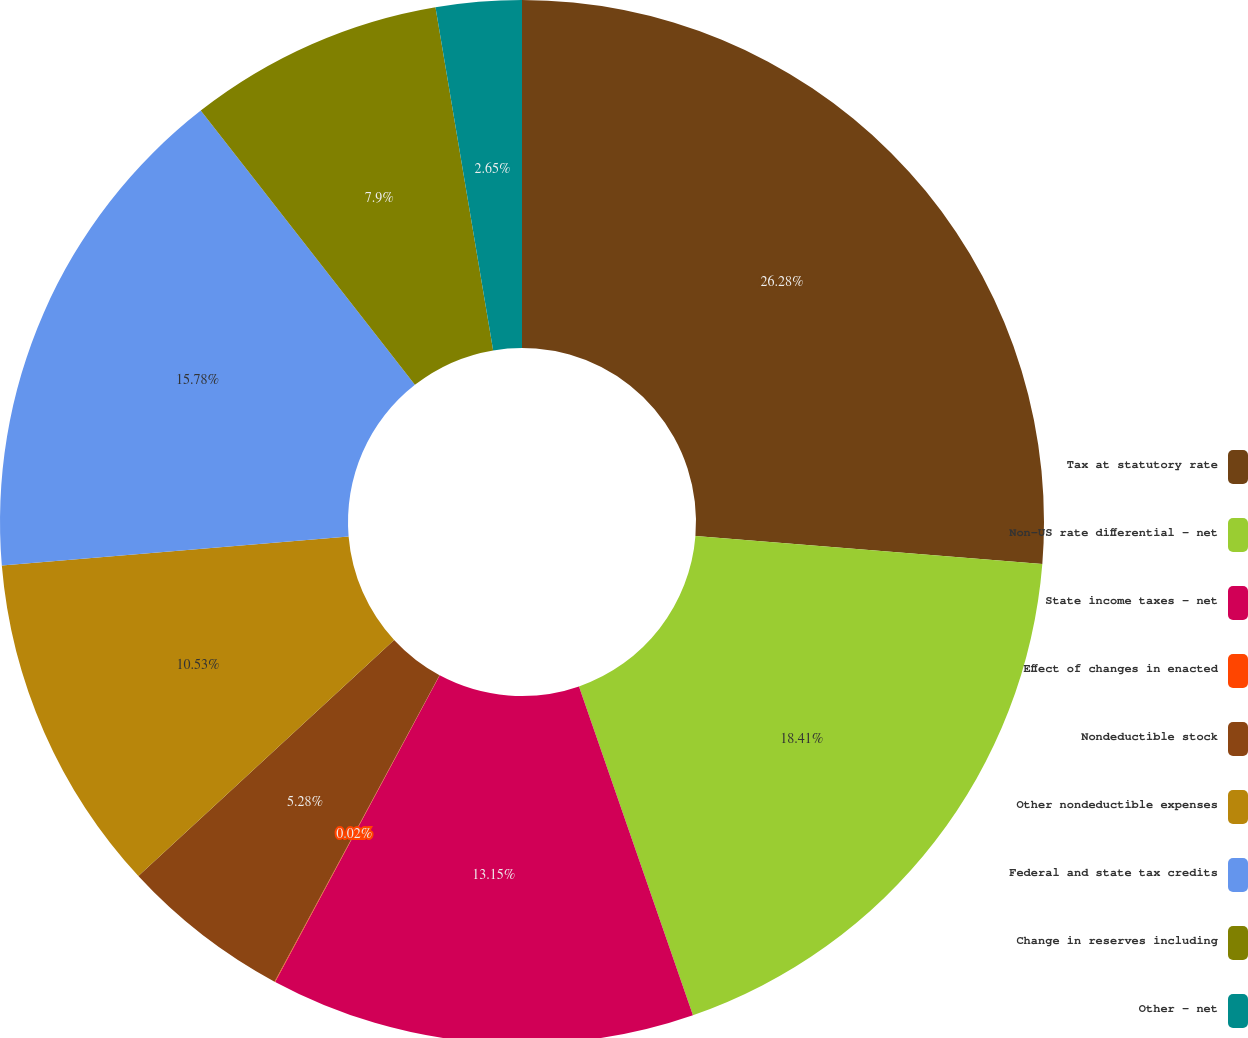Convert chart. <chart><loc_0><loc_0><loc_500><loc_500><pie_chart><fcel>Tax at statutory rate<fcel>Non-US rate differential - net<fcel>State income taxes - net<fcel>Effect of changes in enacted<fcel>Nondeductible stock<fcel>Other nondeductible expenses<fcel>Federal and state tax credits<fcel>Change in reserves including<fcel>Other - net<nl><fcel>26.28%<fcel>18.41%<fcel>13.15%<fcel>0.02%<fcel>5.28%<fcel>10.53%<fcel>15.78%<fcel>7.9%<fcel>2.65%<nl></chart> 